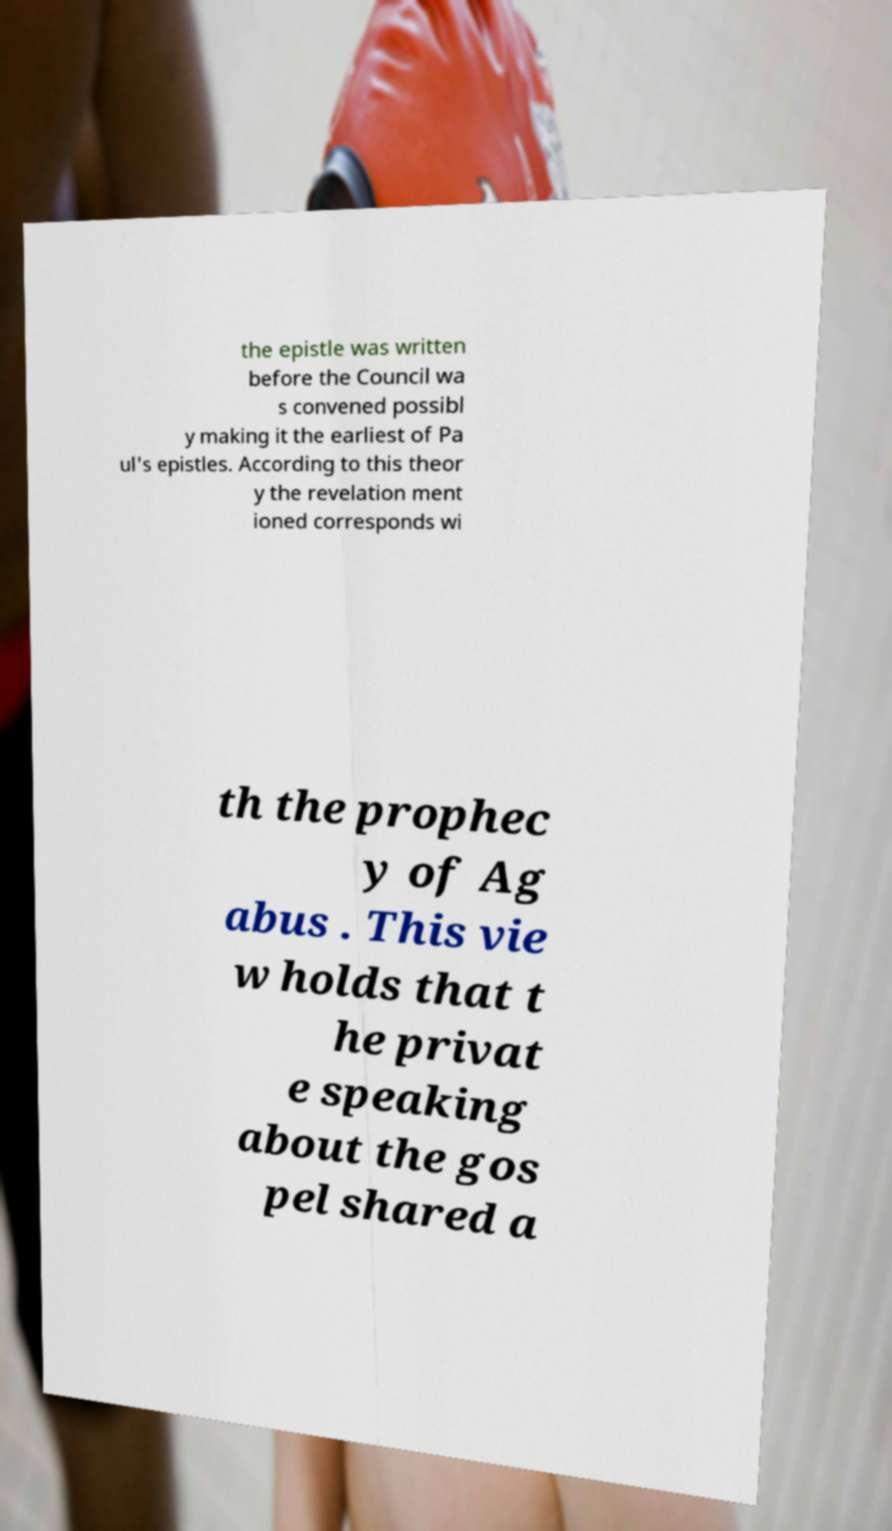Could you extract and type out the text from this image? the epistle was written before the Council wa s convened possibl y making it the earliest of Pa ul's epistles. According to this theor y the revelation ment ioned corresponds wi th the prophec y of Ag abus . This vie w holds that t he privat e speaking about the gos pel shared a 